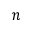Convert formula to latex. <formula><loc_0><loc_0><loc_500><loc_500>n</formula> 